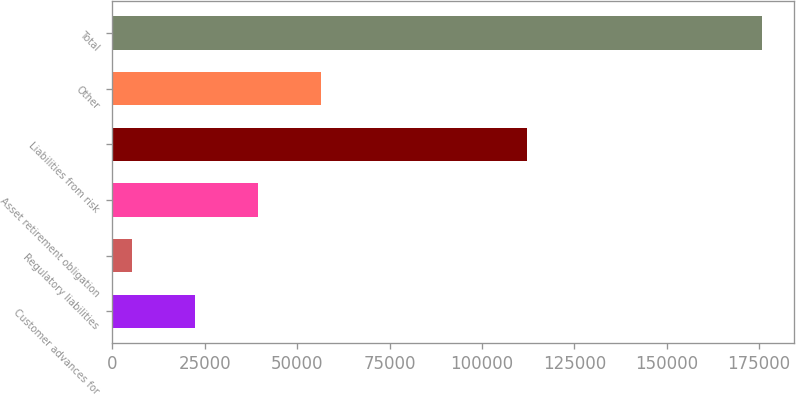Convert chart to OTSL. <chart><loc_0><loc_0><loc_500><loc_500><bar_chart><fcel>Customer advances for<fcel>Regulatory liabilities<fcel>Asset retirement obligation<fcel>Liabilities from risk<fcel>Other<fcel>Total<nl><fcel>22304.8<fcel>5257<fcel>39352.6<fcel>112076<fcel>56400.4<fcel>175735<nl></chart> 